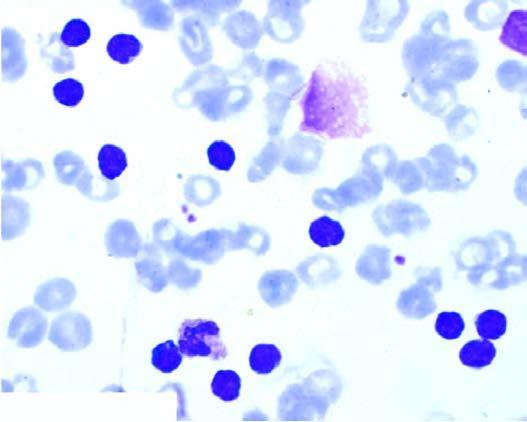what is some degenerated forms appearing as?
Answer the question using a single word or phrase. Bare smudged nuclei 